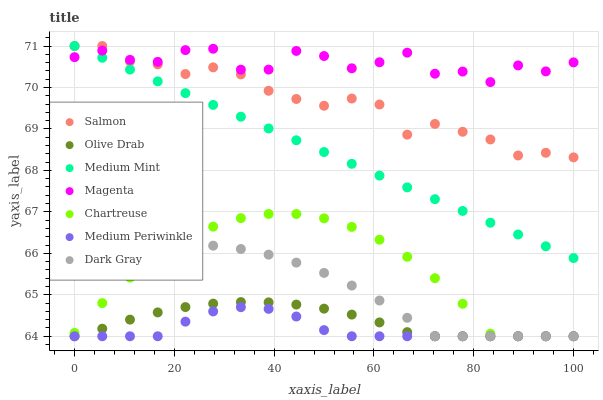Does Medium Periwinkle have the minimum area under the curve?
Answer yes or no. Yes. Does Magenta have the maximum area under the curve?
Answer yes or no. Yes. Does Salmon have the minimum area under the curve?
Answer yes or no. No. Does Salmon have the maximum area under the curve?
Answer yes or no. No. Is Medium Mint the smoothest?
Answer yes or no. Yes. Is Magenta the roughest?
Answer yes or no. Yes. Is Salmon the smoothest?
Answer yes or no. No. Is Salmon the roughest?
Answer yes or no. No. Does Medium Periwinkle have the lowest value?
Answer yes or no. Yes. Does Salmon have the lowest value?
Answer yes or no. No. Does Salmon have the highest value?
Answer yes or no. Yes. Does Medium Periwinkle have the highest value?
Answer yes or no. No. Is Chartreuse less than Salmon?
Answer yes or no. Yes. Is Magenta greater than Dark Gray?
Answer yes or no. Yes. Does Chartreuse intersect Olive Drab?
Answer yes or no. Yes. Is Chartreuse less than Olive Drab?
Answer yes or no. No. Is Chartreuse greater than Olive Drab?
Answer yes or no. No. Does Chartreuse intersect Salmon?
Answer yes or no. No. 